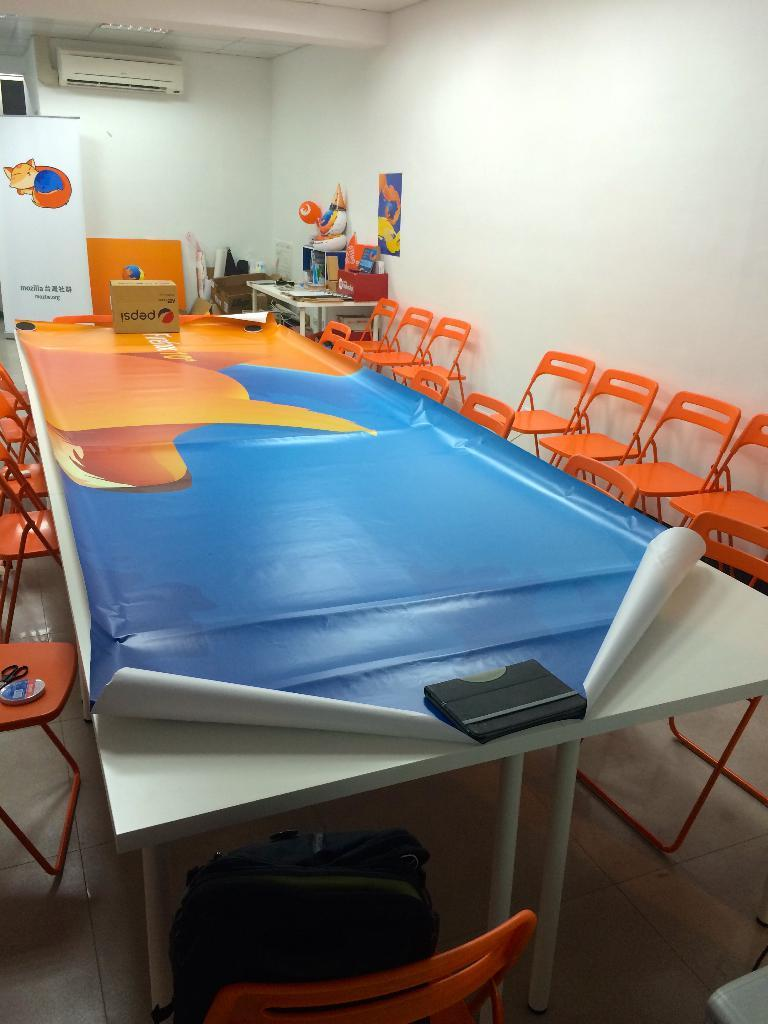What type of furniture can be seen in the image? There are chairs and a table in the image. What are the cardboard cartons used for? The purpose of the cardboard cartons is not specified in the image, but they are present. What is the purpose of the advertisement boards? The advertisement boards are likely used for displaying promotional content or information. What is arranged on the table? Objects are arranged on the table, but their specific nature is not mentioned in the facts. What device is present for cooling the room? There is an air conditioner in the image. What type of polish is being applied to the railway tracks in the image? There is no railway or polish present in the image; it features chairs, a table, cardboard cartons, advertisement boards, objects on the table, and an air conditioner. 